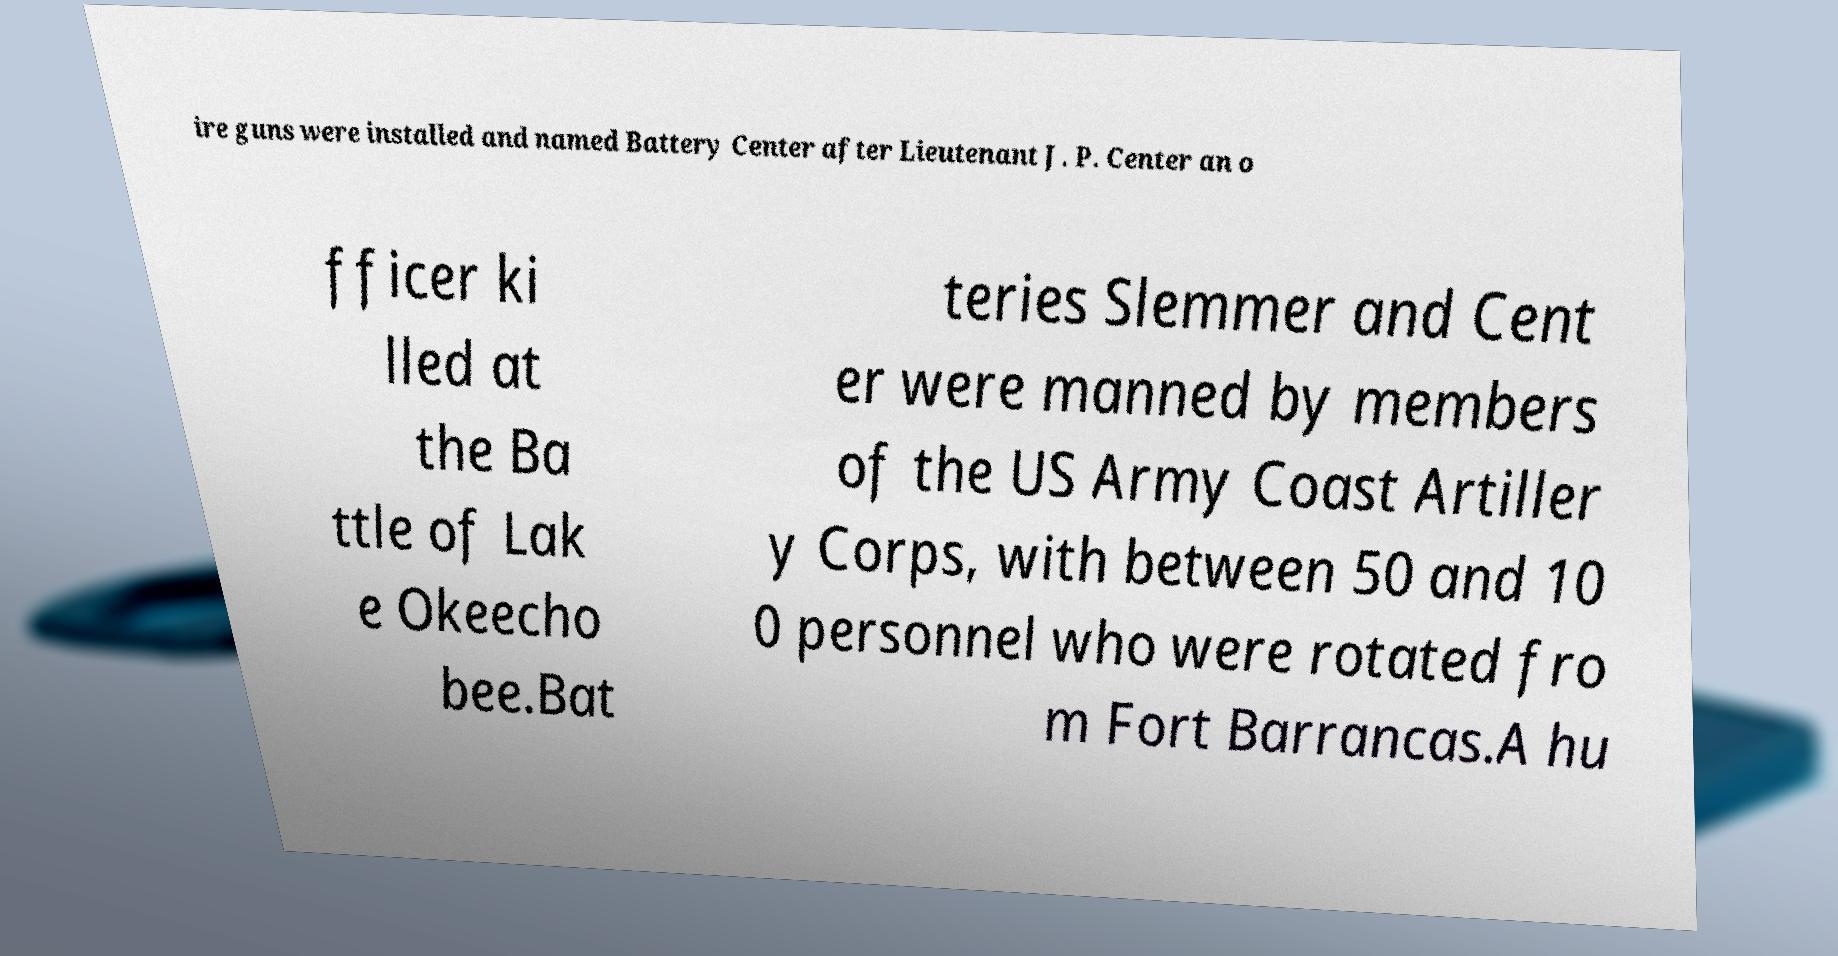Could you extract and type out the text from this image? ire guns were installed and named Battery Center after Lieutenant J. P. Center an o fficer ki lled at the Ba ttle of Lak e Okeecho bee.Bat teries Slemmer and Cent er were manned by members of the US Army Coast Artiller y Corps, with between 50 and 10 0 personnel who were rotated fro m Fort Barrancas.A hu 